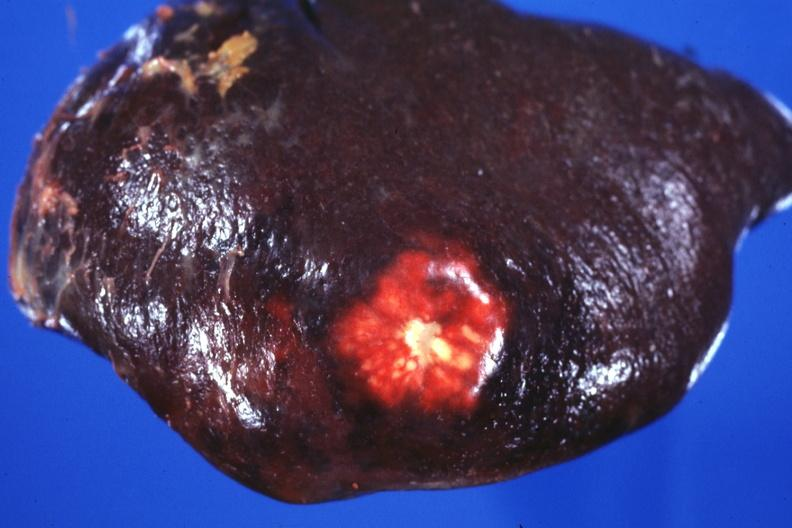how does this image show external view of spleen?
Answer the question using a single word or phrase. With obvious metastatic nodule beneath capsule 